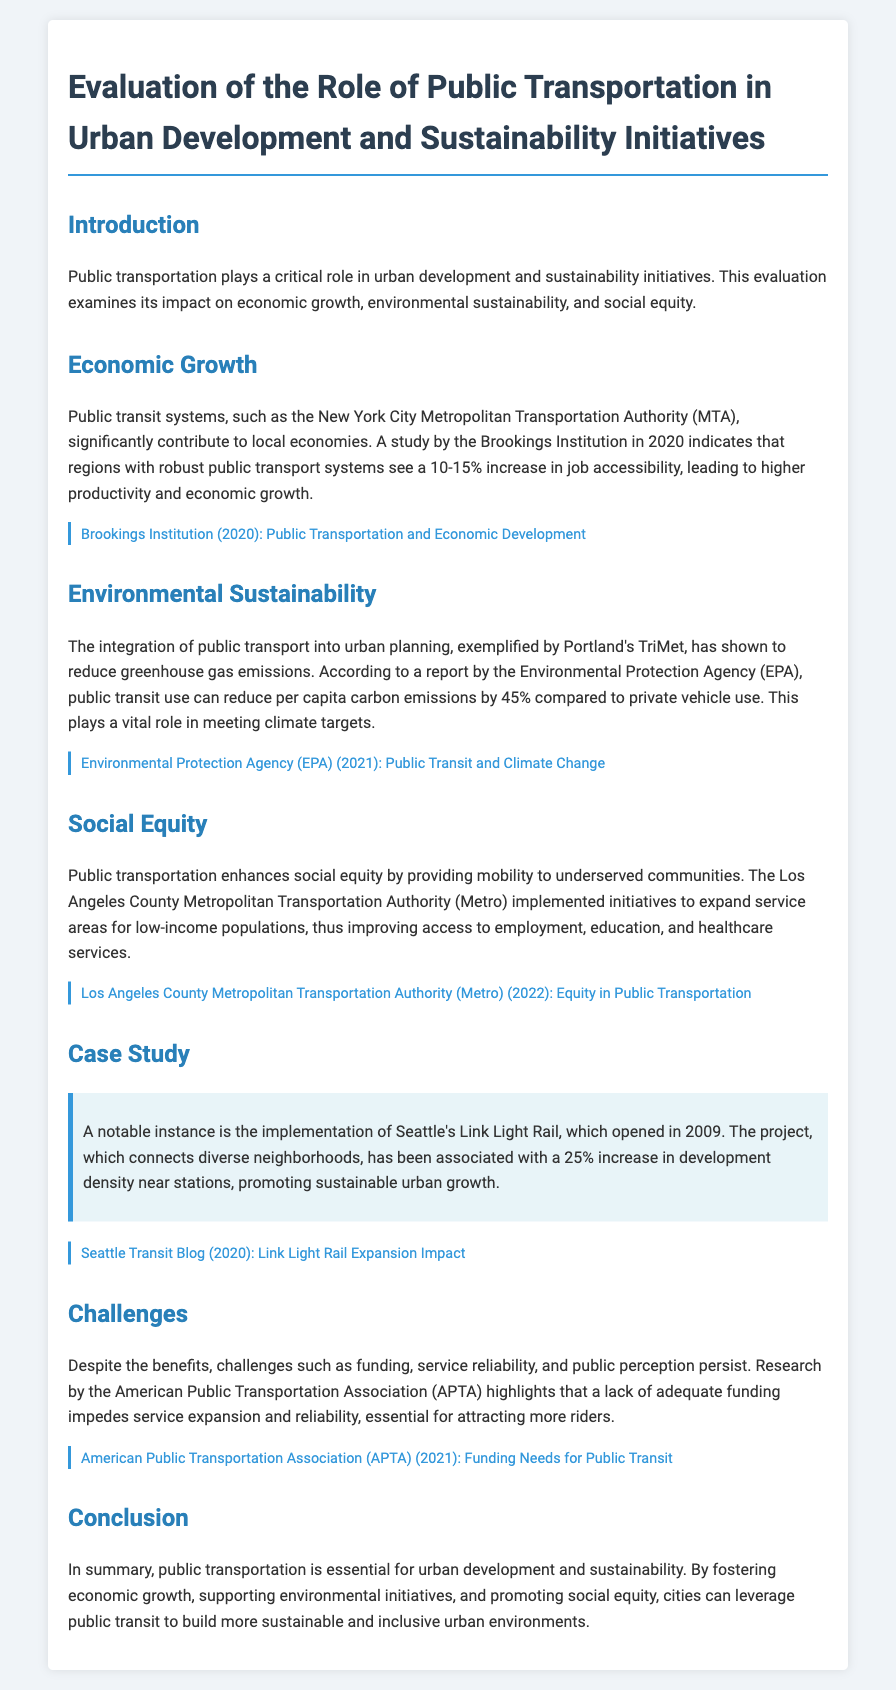What is the role of public transportation in urban development? Public transportation plays a critical role in urban development and sustainability initiatives.
Answer: critical role Which organization conducted a study on job accessibility related to public transport? The Brookings Institution conducted a study regarding job accessibility and public transport systems.
Answer: Brookings Institution What percentage can public transit use reduce per capita carbon emissions compared to private vehicle use? Public transit use can reduce per capita carbon emissions by 45% compared to private vehicle use.
Answer: 45% What was the impact of Seattle's Link Light Rail on development density near stations? The Link Light Rail project has been associated with a 25% increase in development density near stations.
Answer: 25% What challenge related to public transportation is highlighted by the American Public Transportation Association? A lack of adequate funding is highlighted as a challenge impeding service expansion and reliability.
Answer: lack of adequate funding How does public transportation support social equity according to the document? Public transportation enhances social equity by providing mobility to underserved communities.
Answer: mobility to underserved communities What is the publication year of the report by the Environmental Protection Agency on public transit and climate change? The report by the Environmental Protection Agency on public transit and climate change was published in 2021.
Answer: 2021 Which transit system is mentioned for its initiatives to expand service areas for low-income populations? The Los Angeles County Metropolitan Transportation Authority (Metro) is mentioned for its initiatives to expand service areas.
Answer: Los Angeles County Metropolitan Transportation Authority (Metro) What key aspects does public transportation foster according to the conclusion? Public transportation fosters economic growth, supporting environmental initiatives, and promoting social equity.
Answer: economic growth, supporting environmental initiatives, and promoting social equity 